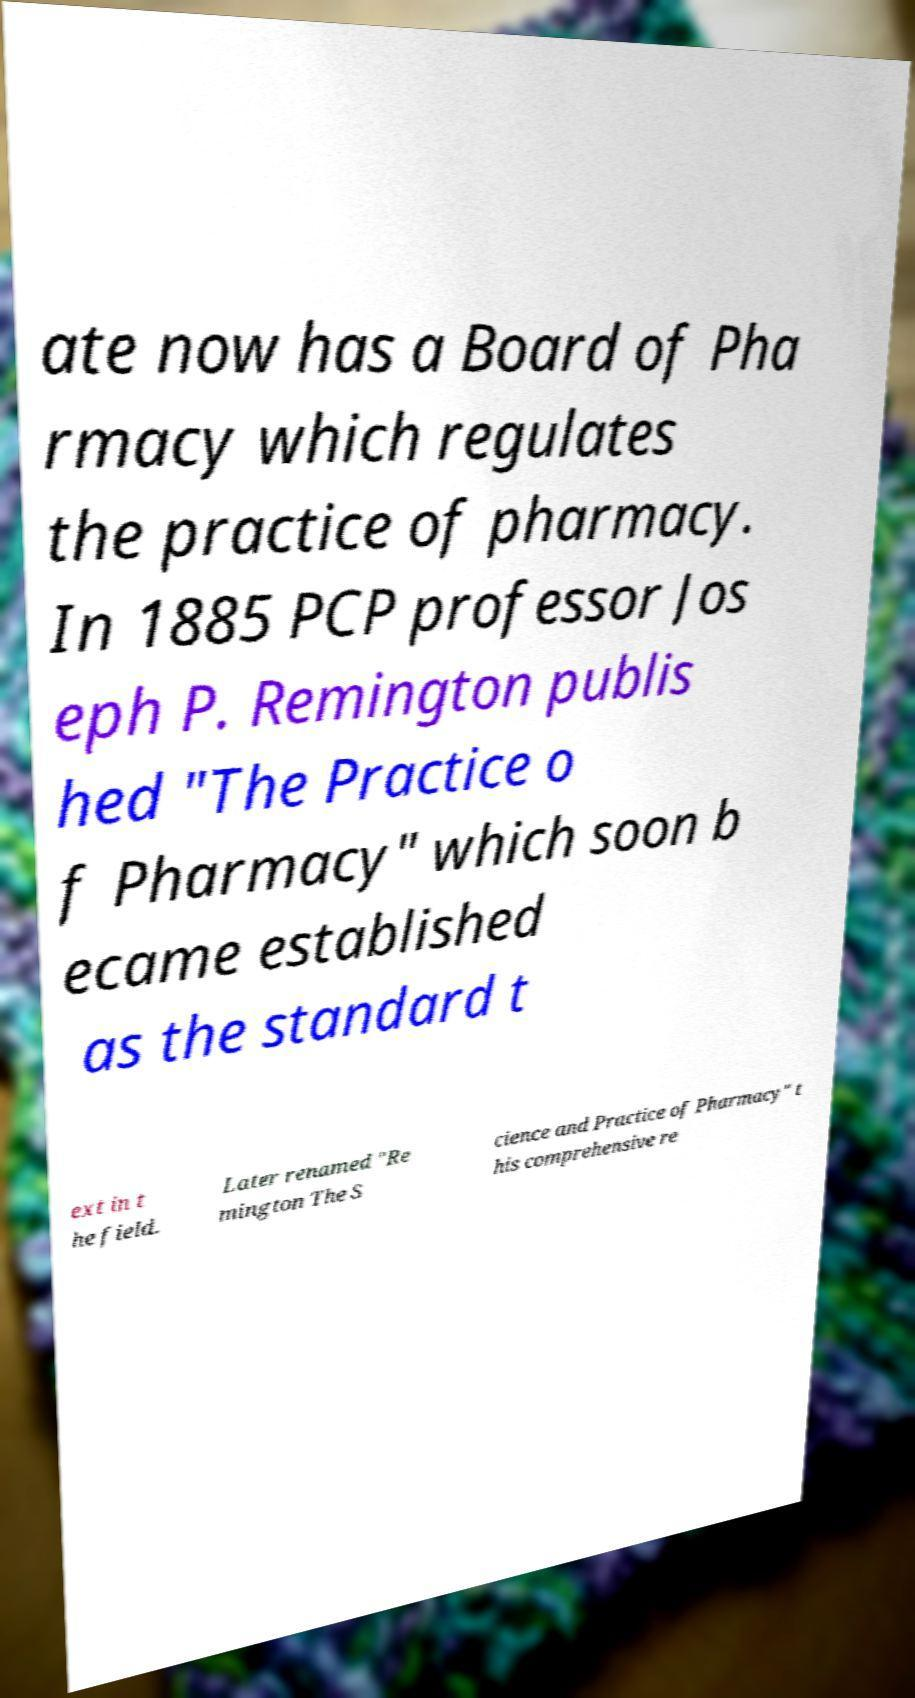What messages or text are displayed in this image? I need them in a readable, typed format. ate now has a Board of Pha rmacy which regulates the practice of pharmacy. In 1885 PCP professor Jos eph P. Remington publis hed "The Practice o f Pharmacy" which soon b ecame established as the standard t ext in t he field. Later renamed "Re mington The S cience and Practice of Pharmacy" t his comprehensive re 